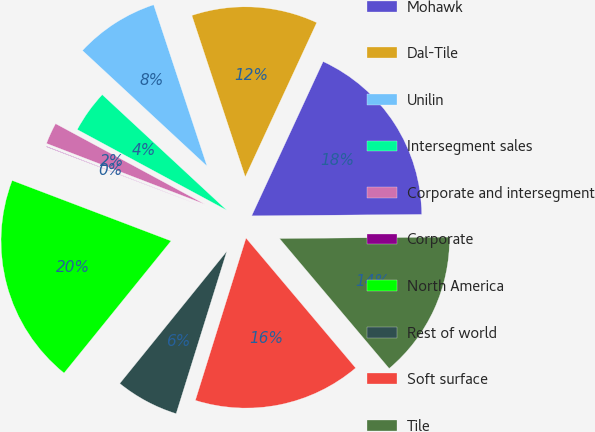Convert chart to OTSL. <chart><loc_0><loc_0><loc_500><loc_500><pie_chart><fcel>Mohawk<fcel>Dal-Tile<fcel>Unilin<fcel>Intersegment sales<fcel>Corporate and intersegment<fcel>Corporate<fcel>North America<fcel>Rest of world<fcel>Soft surface<fcel>Tile<nl><fcel>17.96%<fcel>11.99%<fcel>8.01%<fcel>4.03%<fcel>2.04%<fcel>0.05%<fcel>19.95%<fcel>6.02%<fcel>15.97%<fcel>13.98%<nl></chart> 